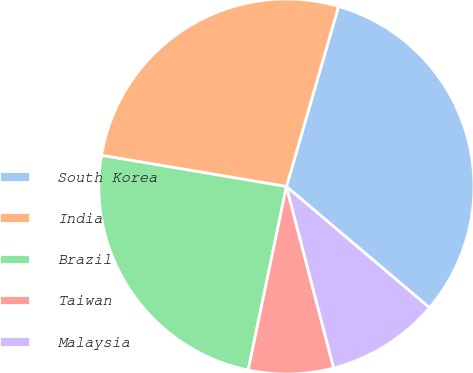Convert chart. <chart><loc_0><loc_0><loc_500><loc_500><pie_chart><fcel>South Korea<fcel>India<fcel>Brazil<fcel>Taiwan<fcel>Malaysia<nl><fcel>31.71%<fcel>26.83%<fcel>24.39%<fcel>7.32%<fcel>9.76%<nl></chart> 